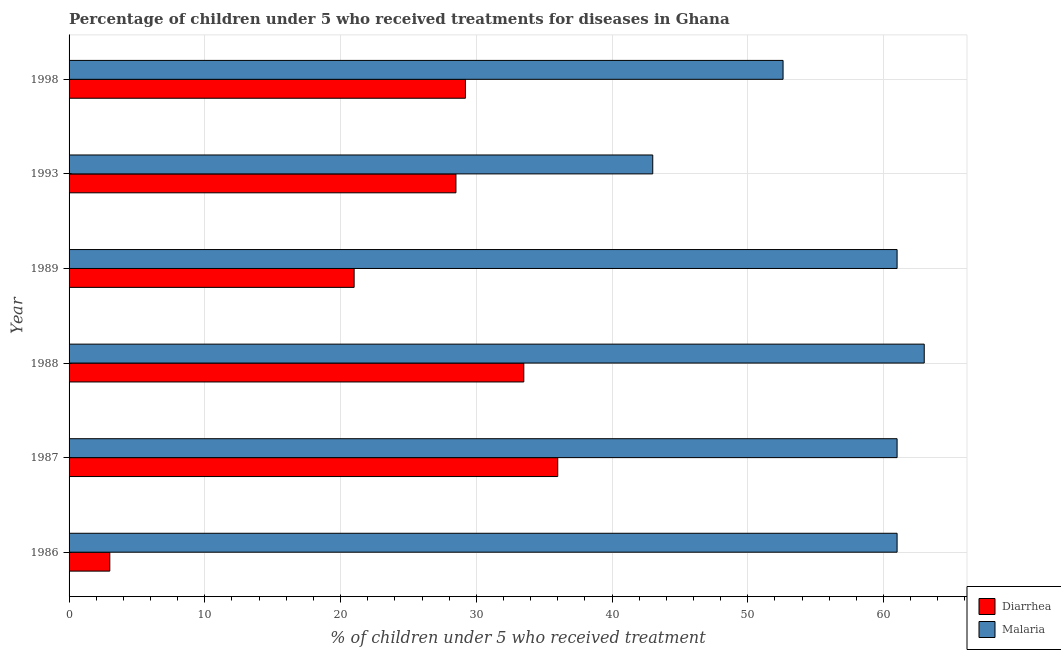How many different coloured bars are there?
Your answer should be compact. 2. How many groups of bars are there?
Your response must be concise. 6. What is the percentage of children who received treatment for malaria in 1998?
Ensure brevity in your answer.  52.6. Across all years, what is the maximum percentage of children who received treatment for malaria?
Offer a very short reply. 63. What is the total percentage of children who received treatment for diarrhoea in the graph?
Offer a terse response. 151.2. What is the difference between the percentage of children who received treatment for diarrhoea in 1986 and the percentage of children who received treatment for malaria in 1993?
Your answer should be compact. -40. What is the average percentage of children who received treatment for diarrhoea per year?
Your response must be concise. 25.2. In how many years, is the percentage of children who received treatment for malaria greater than 24 %?
Keep it short and to the point. 6. What is the ratio of the percentage of children who received treatment for malaria in 1989 to that in 1993?
Your response must be concise. 1.42. What is the difference between the highest and the second highest percentage of children who received treatment for diarrhoea?
Provide a short and direct response. 2.5. What is the difference between the highest and the lowest percentage of children who received treatment for diarrhoea?
Keep it short and to the point. 33. In how many years, is the percentage of children who received treatment for malaria greater than the average percentage of children who received treatment for malaria taken over all years?
Your response must be concise. 4. What does the 1st bar from the top in 1988 represents?
Keep it short and to the point. Malaria. What does the 2nd bar from the bottom in 1987 represents?
Ensure brevity in your answer.  Malaria. Are the values on the major ticks of X-axis written in scientific E-notation?
Your answer should be compact. No. How are the legend labels stacked?
Offer a terse response. Vertical. What is the title of the graph?
Offer a very short reply. Percentage of children under 5 who received treatments for diseases in Ghana. What is the label or title of the X-axis?
Ensure brevity in your answer.  % of children under 5 who received treatment. What is the label or title of the Y-axis?
Keep it short and to the point. Year. What is the % of children under 5 who received treatment of Malaria in 1987?
Provide a succinct answer. 61. What is the % of children under 5 who received treatment of Diarrhea in 1988?
Offer a terse response. 33.5. What is the % of children under 5 who received treatment in Diarrhea in 1998?
Keep it short and to the point. 29.2. What is the % of children under 5 who received treatment in Malaria in 1998?
Your answer should be very brief. 52.6. Across all years, what is the maximum % of children under 5 who received treatment of Malaria?
Offer a terse response. 63. Across all years, what is the minimum % of children under 5 who received treatment of Diarrhea?
Your answer should be very brief. 3. Across all years, what is the minimum % of children under 5 who received treatment of Malaria?
Your answer should be compact. 43. What is the total % of children under 5 who received treatment in Diarrhea in the graph?
Your answer should be very brief. 151.2. What is the total % of children under 5 who received treatment of Malaria in the graph?
Offer a terse response. 341.6. What is the difference between the % of children under 5 who received treatment of Diarrhea in 1986 and that in 1987?
Provide a succinct answer. -33. What is the difference between the % of children under 5 who received treatment in Diarrhea in 1986 and that in 1988?
Offer a very short reply. -30.5. What is the difference between the % of children under 5 who received treatment of Malaria in 1986 and that in 1988?
Keep it short and to the point. -2. What is the difference between the % of children under 5 who received treatment of Diarrhea in 1986 and that in 1993?
Offer a terse response. -25.5. What is the difference between the % of children under 5 who received treatment of Malaria in 1986 and that in 1993?
Provide a short and direct response. 18. What is the difference between the % of children under 5 who received treatment in Diarrhea in 1986 and that in 1998?
Give a very brief answer. -26.2. What is the difference between the % of children under 5 who received treatment in Malaria in 1986 and that in 1998?
Keep it short and to the point. 8.4. What is the difference between the % of children under 5 who received treatment in Diarrhea in 1987 and that in 1988?
Make the answer very short. 2.5. What is the difference between the % of children under 5 who received treatment in Malaria in 1987 and that in 1988?
Keep it short and to the point. -2. What is the difference between the % of children under 5 who received treatment in Diarrhea in 1987 and that in 1989?
Your response must be concise. 15. What is the difference between the % of children under 5 who received treatment of Malaria in 1987 and that in 1989?
Give a very brief answer. 0. What is the difference between the % of children under 5 who received treatment in Diarrhea in 1987 and that in 1993?
Provide a succinct answer. 7.5. What is the difference between the % of children under 5 who received treatment of Diarrhea in 1987 and that in 1998?
Your response must be concise. 6.8. What is the difference between the % of children under 5 who received treatment in Diarrhea in 1988 and that in 1989?
Provide a short and direct response. 12.5. What is the difference between the % of children under 5 who received treatment in Malaria in 1988 and that in 1989?
Offer a terse response. 2. What is the difference between the % of children under 5 who received treatment of Diarrhea in 1989 and that in 1993?
Provide a short and direct response. -7.5. What is the difference between the % of children under 5 who received treatment of Diarrhea in 1993 and that in 1998?
Provide a succinct answer. -0.7. What is the difference between the % of children under 5 who received treatment in Malaria in 1993 and that in 1998?
Provide a short and direct response. -9.6. What is the difference between the % of children under 5 who received treatment in Diarrhea in 1986 and the % of children under 5 who received treatment in Malaria in 1987?
Keep it short and to the point. -58. What is the difference between the % of children under 5 who received treatment in Diarrhea in 1986 and the % of children under 5 who received treatment in Malaria in 1988?
Provide a short and direct response. -60. What is the difference between the % of children under 5 who received treatment in Diarrhea in 1986 and the % of children under 5 who received treatment in Malaria in 1989?
Your response must be concise. -58. What is the difference between the % of children under 5 who received treatment in Diarrhea in 1986 and the % of children under 5 who received treatment in Malaria in 1998?
Provide a short and direct response. -49.6. What is the difference between the % of children under 5 who received treatment of Diarrhea in 1987 and the % of children under 5 who received treatment of Malaria in 1989?
Your answer should be compact. -25. What is the difference between the % of children under 5 who received treatment in Diarrhea in 1987 and the % of children under 5 who received treatment in Malaria in 1993?
Your answer should be compact. -7. What is the difference between the % of children under 5 who received treatment of Diarrhea in 1987 and the % of children under 5 who received treatment of Malaria in 1998?
Keep it short and to the point. -16.6. What is the difference between the % of children under 5 who received treatment of Diarrhea in 1988 and the % of children under 5 who received treatment of Malaria in 1989?
Make the answer very short. -27.5. What is the difference between the % of children under 5 who received treatment in Diarrhea in 1988 and the % of children under 5 who received treatment in Malaria in 1998?
Ensure brevity in your answer.  -19.1. What is the difference between the % of children under 5 who received treatment in Diarrhea in 1989 and the % of children under 5 who received treatment in Malaria in 1993?
Ensure brevity in your answer.  -22. What is the difference between the % of children under 5 who received treatment in Diarrhea in 1989 and the % of children under 5 who received treatment in Malaria in 1998?
Provide a short and direct response. -31.6. What is the difference between the % of children under 5 who received treatment in Diarrhea in 1993 and the % of children under 5 who received treatment in Malaria in 1998?
Provide a short and direct response. -24.1. What is the average % of children under 5 who received treatment in Diarrhea per year?
Provide a succinct answer. 25.2. What is the average % of children under 5 who received treatment of Malaria per year?
Ensure brevity in your answer.  56.93. In the year 1986, what is the difference between the % of children under 5 who received treatment of Diarrhea and % of children under 5 who received treatment of Malaria?
Your answer should be compact. -58. In the year 1988, what is the difference between the % of children under 5 who received treatment of Diarrhea and % of children under 5 who received treatment of Malaria?
Provide a succinct answer. -29.5. In the year 1998, what is the difference between the % of children under 5 who received treatment in Diarrhea and % of children under 5 who received treatment in Malaria?
Ensure brevity in your answer.  -23.4. What is the ratio of the % of children under 5 who received treatment of Diarrhea in 1986 to that in 1987?
Your answer should be compact. 0.08. What is the ratio of the % of children under 5 who received treatment of Malaria in 1986 to that in 1987?
Your answer should be compact. 1. What is the ratio of the % of children under 5 who received treatment of Diarrhea in 1986 to that in 1988?
Ensure brevity in your answer.  0.09. What is the ratio of the % of children under 5 who received treatment of Malaria in 1986 to that in 1988?
Your answer should be compact. 0.97. What is the ratio of the % of children under 5 who received treatment of Diarrhea in 1986 to that in 1989?
Your answer should be compact. 0.14. What is the ratio of the % of children under 5 who received treatment of Malaria in 1986 to that in 1989?
Provide a short and direct response. 1. What is the ratio of the % of children under 5 who received treatment in Diarrhea in 1986 to that in 1993?
Ensure brevity in your answer.  0.11. What is the ratio of the % of children under 5 who received treatment in Malaria in 1986 to that in 1993?
Your answer should be very brief. 1.42. What is the ratio of the % of children under 5 who received treatment in Diarrhea in 1986 to that in 1998?
Keep it short and to the point. 0.1. What is the ratio of the % of children under 5 who received treatment of Malaria in 1986 to that in 1998?
Give a very brief answer. 1.16. What is the ratio of the % of children under 5 who received treatment of Diarrhea in 1987 to that in 1988?
Your response must be concise. 1.07. What is the ratio of the % of children under 5 who received treatment in Malaria in 1987 to that in 1988?
Provide a succinct answer. 0.97. What is the ratio of the % of children under 5 who received treatment in Diarrhea in 1987 to that in 1989?
Your answer should be compact. 1.71. What is the ratio of the % of children under 5 who received treatment in Malaria in 1987 to that in 1989?
Give a very brief answer. 1. What is the ratio of the % of children under 5 who received treatment of Diarrhea in 1987 to that in 1993?
Make the answer very short. 1.26. What is the ratio of the % of children under 5 who received treatment of Malaria in 1987 to that in 1993?
Your response must be concise. 1.42. What is the ratio of the % of children under 5 who received treatment in Diarrhea in 1987 to that in 1998?
Keep it short and to the point. 1.23. What is the ratio of the % of children under 5 who received treatment in Malaria in 1987 to that in 1998?
Your answer should be very brief. 1.16. What is the ratio of the % of children under 5 who received treatment of Diarrhea in 1988 to that in 1989?
Your answer should be compact. 1.6. What is the ratio of the % of children under 5 who received treatment in Malaria in 1988 to that in 1989?
Your response must be concise. 1.03. What is the ratio of the % of children under 5 who received treatment in Diarrhea in 1988 to that in 1993?
Provide a short and direct response. 1.18. What is the ratio of the % of children under 5 who received treatment of Malaria in 1988 to that in 1993?
Make the answer very short. 1.47. What is the ratio of the % of children under 5 who received treatment in Diarrhea in 1988 to that in 1998?
Offer a terse response. 1.15. What is the ratio of the % of children under 5 who received treatment of Malaria in 1988 to that in 1998?
Give a very brief answer. 1.2. What is the ratio of the % of children under 5 who received treatment of Diarrhea in 1989 to that in 1993?
Your answer should be very brief. 0.74. What is the ratio of the % of children under 5 who received treatment of Malaria in 1989 to that in 1993?
Give a very brief answer. 1.42. What is the ratio of the % of children under 5 who received treatment of Diarrhea in 1989 to that in 1998?
Provide a short and direct response. 0.72. What is the ratio of the % of children under 5 who received treatment in Malaria in 1989 to that in 1998?
Provide a short and direct response. 1.16. What is the ratio of the % of children under 5 who received treatment of Diarrhea in 1993 to that in 1998?
Your answer should be compact. 0.98. What is the ratio of the % of children under 5 who received treatment in Malaria in 1993 to that in 1998?
Ensure brevity in your answer.  0.82. What is the difference between the highest and the second highest % of children under 5 who received treatment of Diarrhea?
Provide a succinct answer. 2.5. What is the difference between the highest and the lowest % of children under 5 who received treatment of Diarrhea?
Provide a succinct answer. 33. 